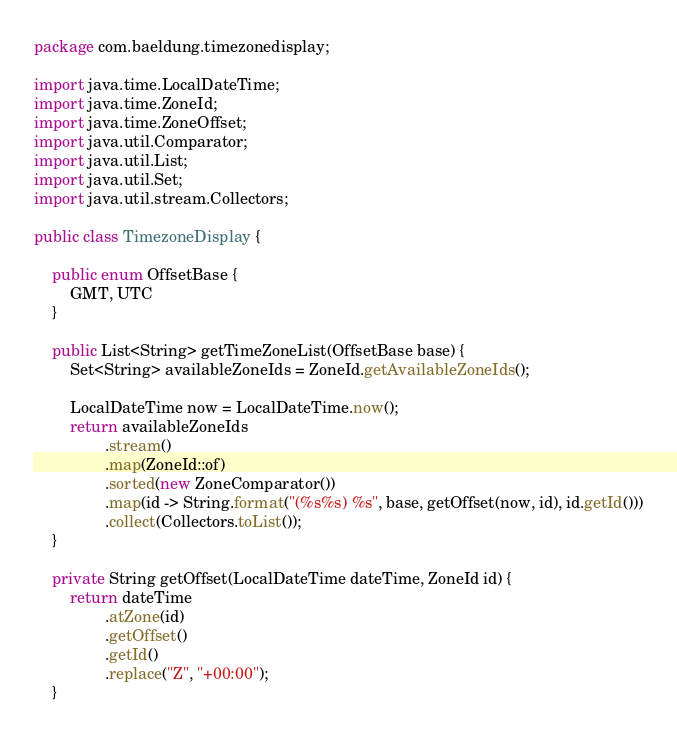Convert code to text. <code><loc_0><loc_0><loc_500><loc_500><_Java_>package com.baeldung.timezonedisplay;

import java.time.LocalDateTime;
import java.time.ZoneId;
import java.time.ZoneOffset;
import java.util.Comparator;
import java.util.List;
import java.util.Set;
import java.util.stream.Collectors;

public class TimezoneDisplay {

    public enum OffsetBase {
        GMT, UTC
    }

    public List<String> getTimeZoneList(OffsetBase base) {
        Set<String> availableZoneIds = ZoneId.getAvailableZoneIds();

        LocalDateTime now = LocalDateTime.now();
        return availableZoneIds
                .stream()
                .map(ZoneId::of)
                .sorted(new ZoneComparator())
                .map(id -> String.format("(%s%s) %s", base, getOffset(now, id), id.getId()))
                .collect(Collectors.toList());
    }

    private String getOffset(LocalDateTime dateTime, ZoneId id) {
        return dateTime
                .atZone(id)
                .getOffset()
                .getId()
                .replace("Z", "+00:00");
    }
</code> 